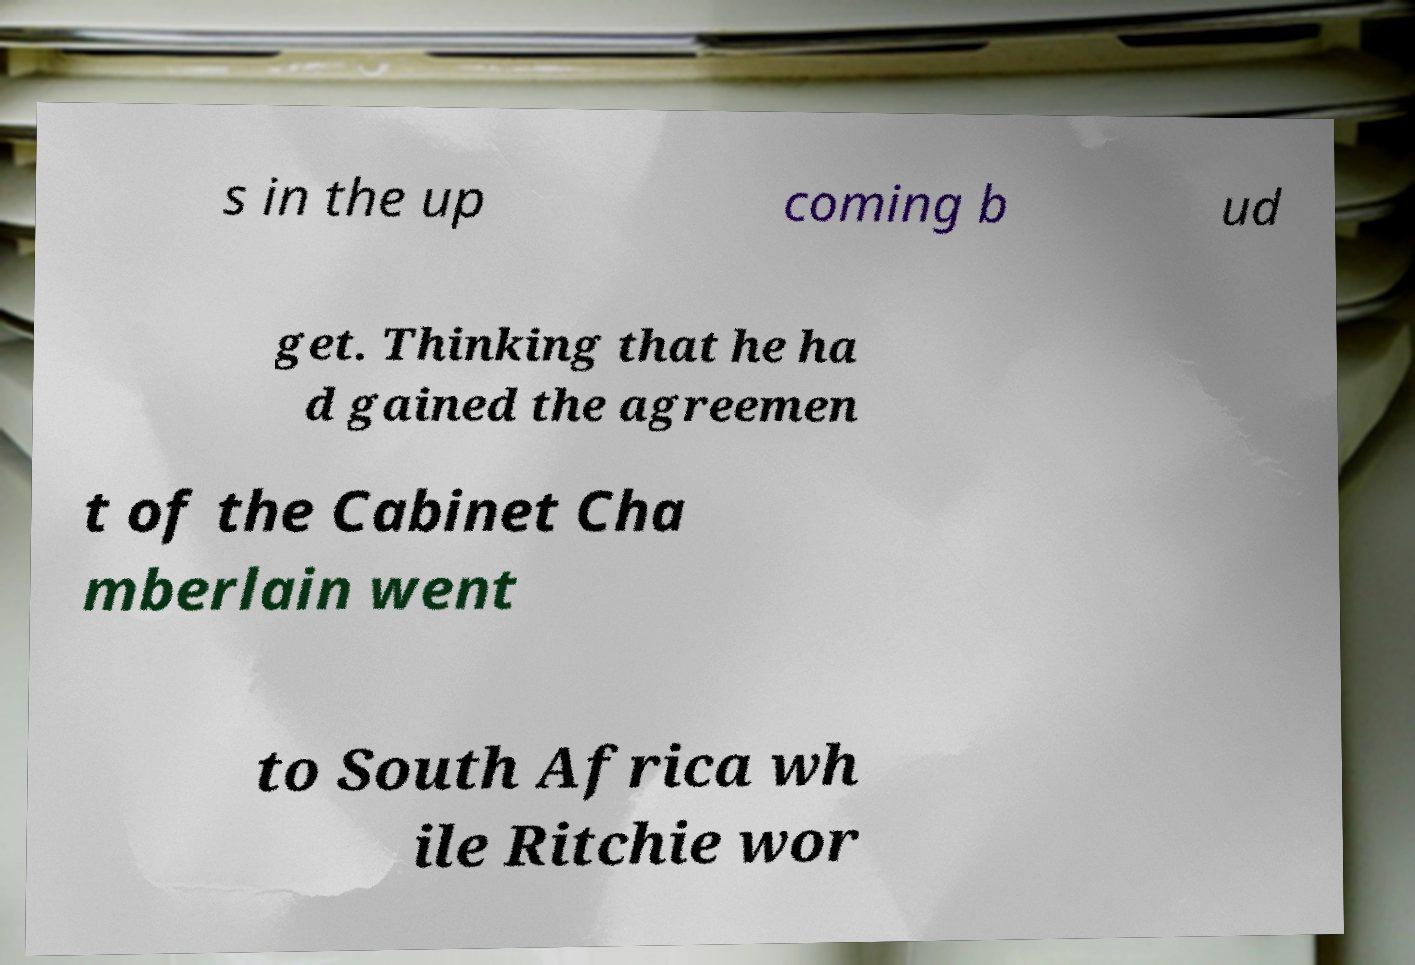For documentation purposes, I need the text within this image transcribed. Could you provide that? s in the up coming b ud get. Thinking that he ha d gained the agreemen t of the Cabinet Cha mberlain went to South Africa wh ile Ritchie wor 